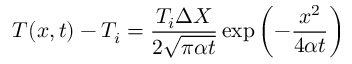<formula> <loc_0><loc_0><loc_500><loc_500>T ( x , t ) - T _ { i } = { \frac { T _ { i } \Delta X } { 2 { \sqrt { \pi \alpha t } } } } \exp \left ( - { \frac { x ^ { 2 } } { 4 \alpha t } } \right )</formula> 